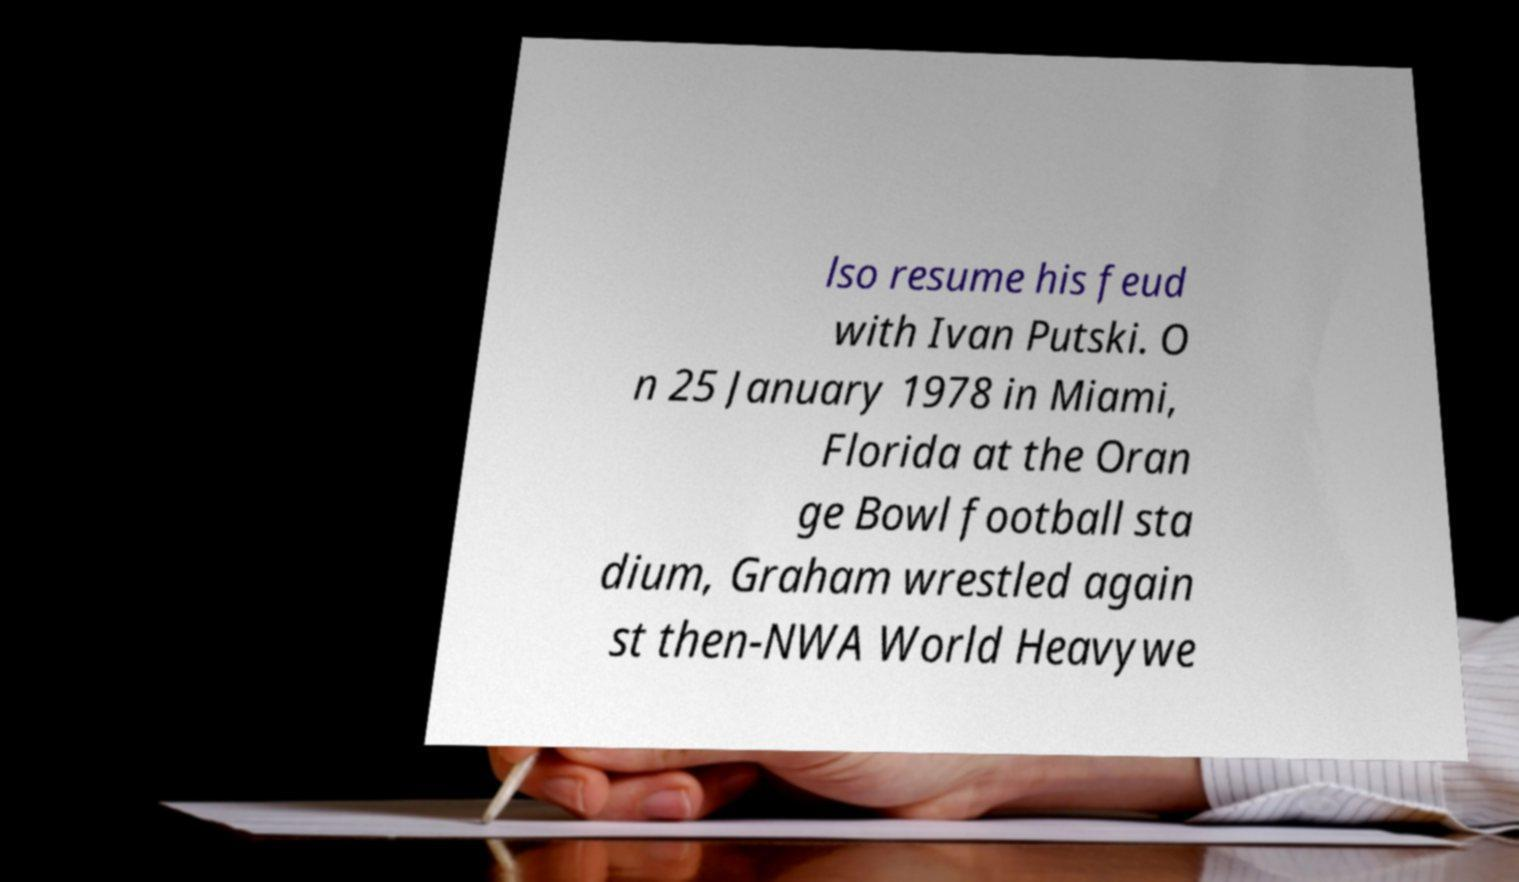Can you accurately transcribe the text from the provided image for me? lso resume his feud with Ivan Putski. O n 25 January 1978 in Miami, Florida at the Oran ge Bowl football sta dium, Graham wrestled again st then-NWA World Heavywe 